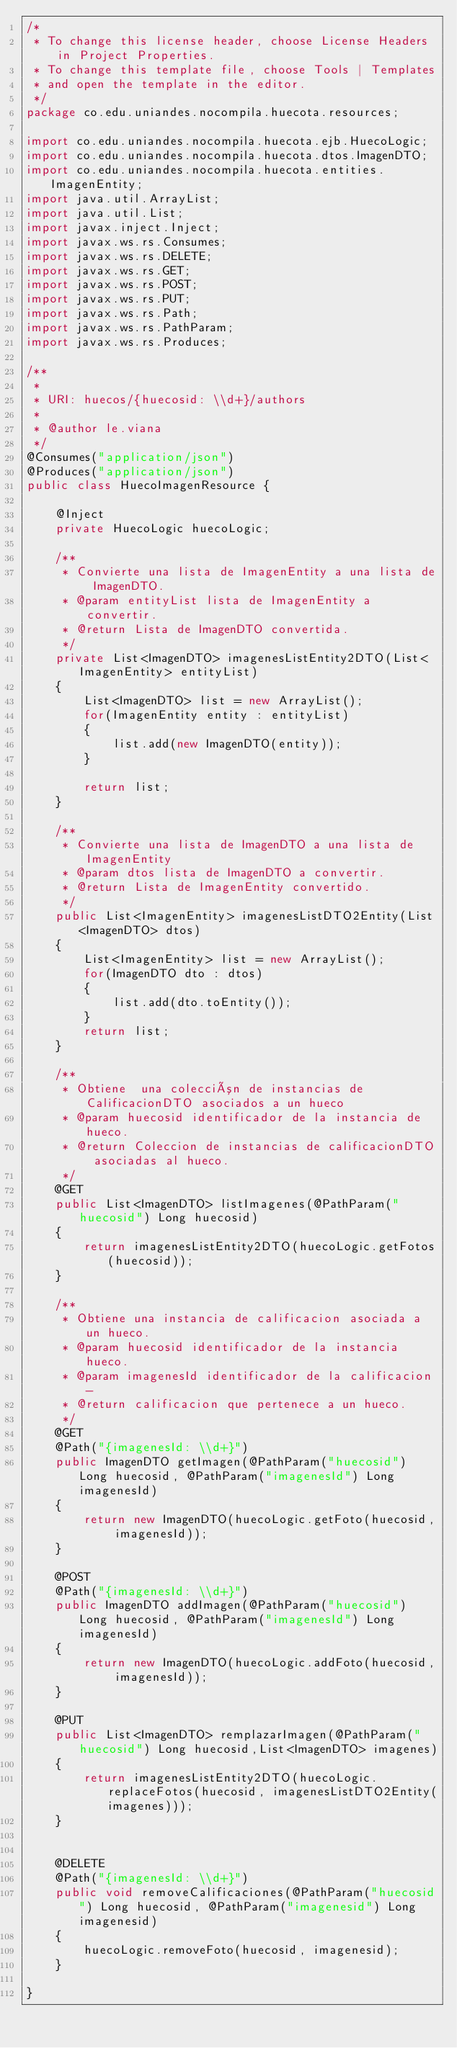<code> <loc_0><loc_0><loc_500><loc_500><_Java_>/*
 * To change this license header, choose License Headers in Project Properties.
 * To change this template file, choose Tools | Templates
 * and open the template in the editor.
 */
package co.edu.uniandes.nocompila.huecota.resources;

import co.edu.uniandes.nocompila.huecota.ejb.HuecoLogic;
import co.edu.uniandes.nocompila.huecota.dtos.ImagenDTO;
import co.edu.uniandes.nocompila.huecota.entities.ImagenEntity;
import java.util.ArrayList;
import java.util.List;
import javax.inject.Inject;
import javax.ws.rs.Consumes;
import javax.ws.rs.DELETE;
import javax.ws.rs.GET;
import javax.ws.rs.POST;
import javax.ws.rs.PUT;
import javax.ws.rs.Path;
import javax.ws.rs.PathParam;
import javax.ws.rs.Produces;

/**
 * 
 * URI: huecos/{huecosid: \\d+}/authors
 *
 * @author le.viana
 */
@Consumes("application/json")
@Produces("application/json")
public class HuecoImagenResource {
    
    @Inject
    private HuecoLogic huecoLogic;
    
    /**
     * Convierte una lista de ImagenEntity a una lista de ImagenDTO.
     * @param entityList lista de ImagenEntity a convertir.
     * @return Lista de ImagenDTO convertida.
     */
    private List<ImagenDTO> imagenesListEntity2DTO(List<ImagenEntity> entityList)
    {
        List<ImagenDTO> list = new ArrayList();
        for(ImagenEntity entity : entityList)
        {
            list.add(new ImagenDTO(entity));
        }
        
        return list;
    }
    
    /**
     * Convierte una lista de ImagenDTO a una lista de ImagenEntity
     * @param dtos lista de ImagenDTO a convertir.
     * @return Lista de ImagenEntity convertido.
     */
    public List<ImagenEntity> imagenesListDTO2Entity(List<ImagenDTO> dtos)
    {
        List<ImagenEntity> list = new ArrayList();
        for(ImagenDTO dto : dtos)
        {
            list.add(dto.toEntity());
        }
        return list;
    }
    
    /**
     * Obtiene  una colección de instancias de CalificacionDTO asociados a un hueco
     * @param huecosid identificador de la instancia de hueco.
     * @return Coleccion de instancias de calificacionDTO asociadas al hueco.
     */
    @GET
    public List<ImagenDTO> listImagenes(@PathParam("huecosid") Long huecosid)
    {
        return imagenesListEntity2DTO(huecoLogic.getFotos(huecosid));
    }
    
    /**
     * Obtiene una instancia de calificacion asociada a un hueco.
     * @param huecosid identificador de la instancia hueco.
     * @param imagenesId identificador de la calificacion-
     * @return calificacion que pertenece a un hueco.
     */
    @GET
    @Path("{imagenesId: \\d+}")
    public ImagenDTO getImagen(@PathParam("huecosid") Long huecosid, @PathParam("imagenesId") Long imagenesId)
    {
        return new ImagenDTO(huecoLogic.getFoto(huecosid, imagenesId));
    }
    
    @POST
    @Path("{imagenesId: \\d+}")
    public ImagenDTO addImagen(@PathParam("huecosid") Long huecosid, @PathParam("imagenesId") Long imagenesId)
    {
        return new ImagenDTO(huecoLogic.addFoto(huecosid, imagenesId));
    }
    
    @PUT
    public List<ImagenDTO> remplazarImagen(@PathParam("huecosid") Long huecosid,List<ImagenDTO> imagenes)
    {
        return imagenesListEntity2DTO(huecoLogic.replaceFotos(huecosid, imagenesListDTO2Entity(imagenes)));
    }
    
    
    @DELETE
    @Path("{imagenesId: \\d+}")
    public void removeCalificaciones(@PathParam("huecosid") Long huecosid, @PathParam("imagenesid") Long imagenesid)
    {
        huecoLogic.removeFoto(huecosid, imagenesid);
    }
    
}
</code> 